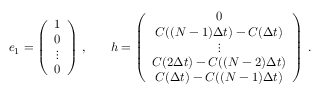Convert formula to latex. <formula><loc_0><loc_0><loc_500><loc_500>\begin{array} { r l } { e _ { 1 } = \left ( \begin{array} { c } { 1 } \\ { 0 } \\ { \vdots } \\ { 0 } \end{array} \right ) \, , } & \quad h = \left ( \begin{array} { c } { 0 } \\ { C ( ( N - 1 ) \Delta t ) - C ( \Delta t ) } \\ { \vdots } \\ { C ( 2 \Delta t ) - C ( ( N - 2 ) \Delta t ) } \\ { C ( \Delta t ) - C ( ( N - 1 ) \Delta t ) } \end{array} \right ) \, . } \end{array}</formula> 